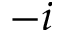Convert formula to latex. <formula><loc_0><loc_0><loc_500><loc_500>- i</formula> 